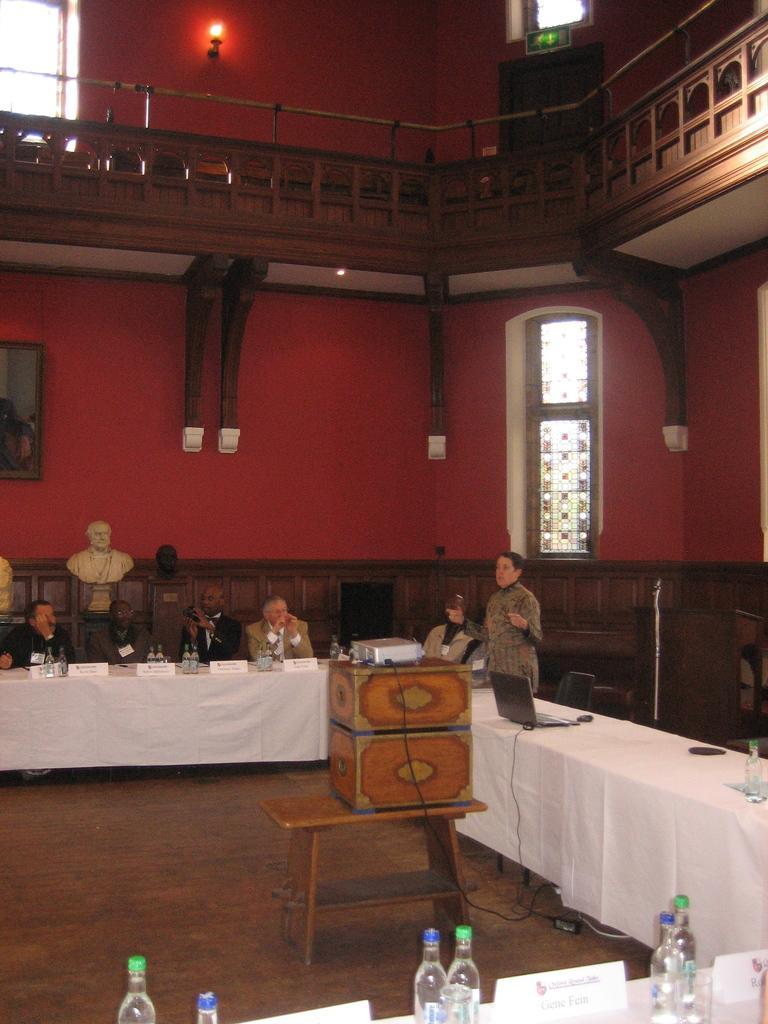Can you describe this image briefly? in this picture could see couple of persons sitting on the table. The table is white in color and in the background there is red color wall. 